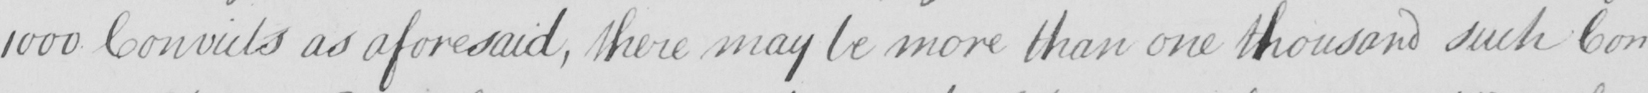Can you tell me what this handwritten text says? 1000 Convicts as aforesaid , there may be more than one thousand such Con- 